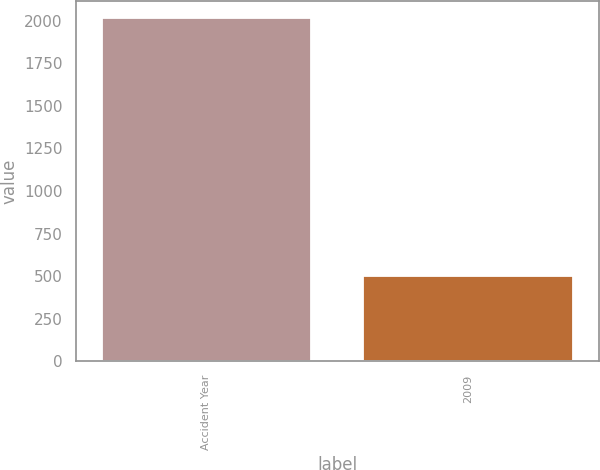Convert chart. <chart><loc_0><loc_0><loc_500><loc_500><bar_chart><fcel>Accident Year<fcel>2009<nl><fcel>2013<fcel>503<nl></chart> 